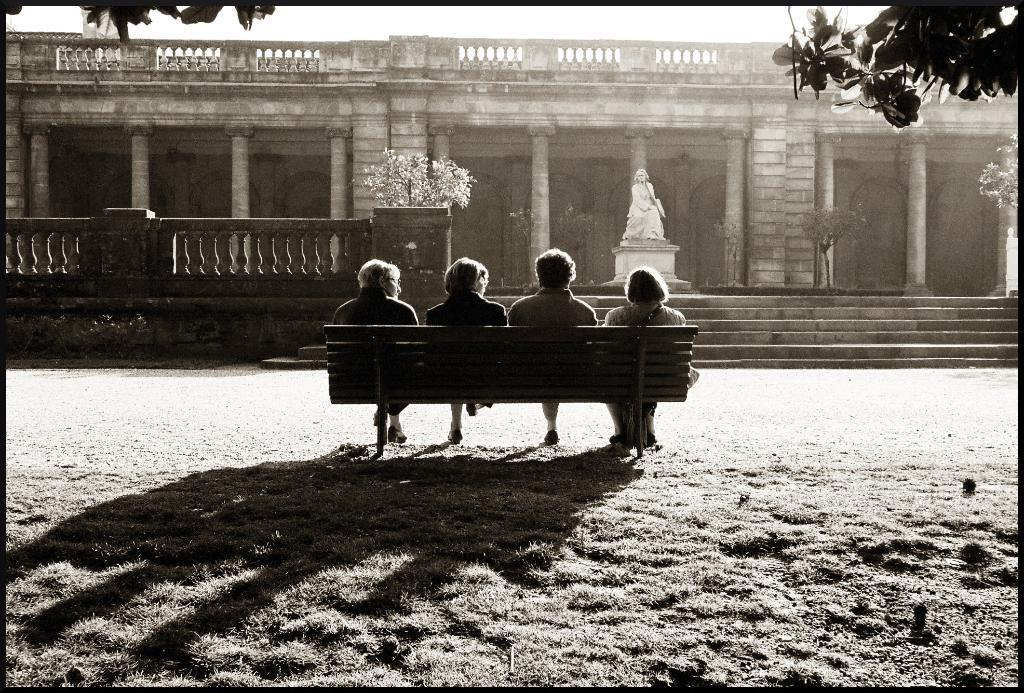How would you summarize this image in a sentence or two? In this picture there are four people sitting on the stand in the background there is a building. 